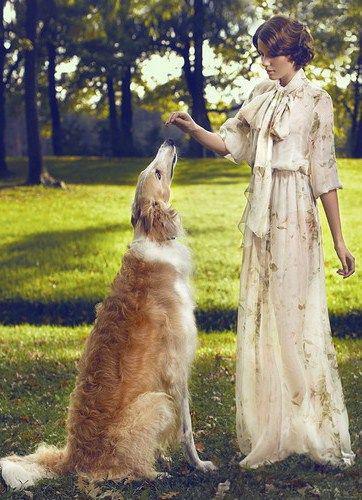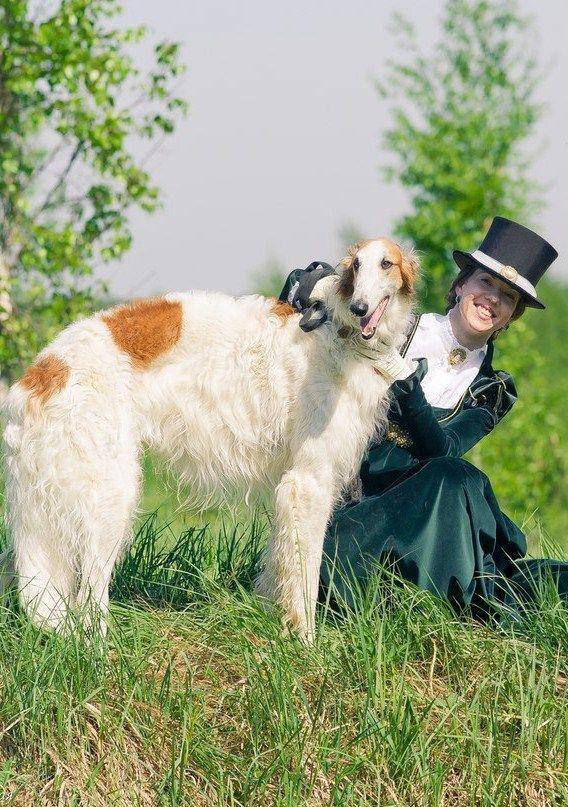The first image is the image on the left, the second image is the image on the right. Examine the images to the left and right. Is the description "Each image features one dog, and the dogs are facing opposite directions." accurate? Answer yes or no. No. 